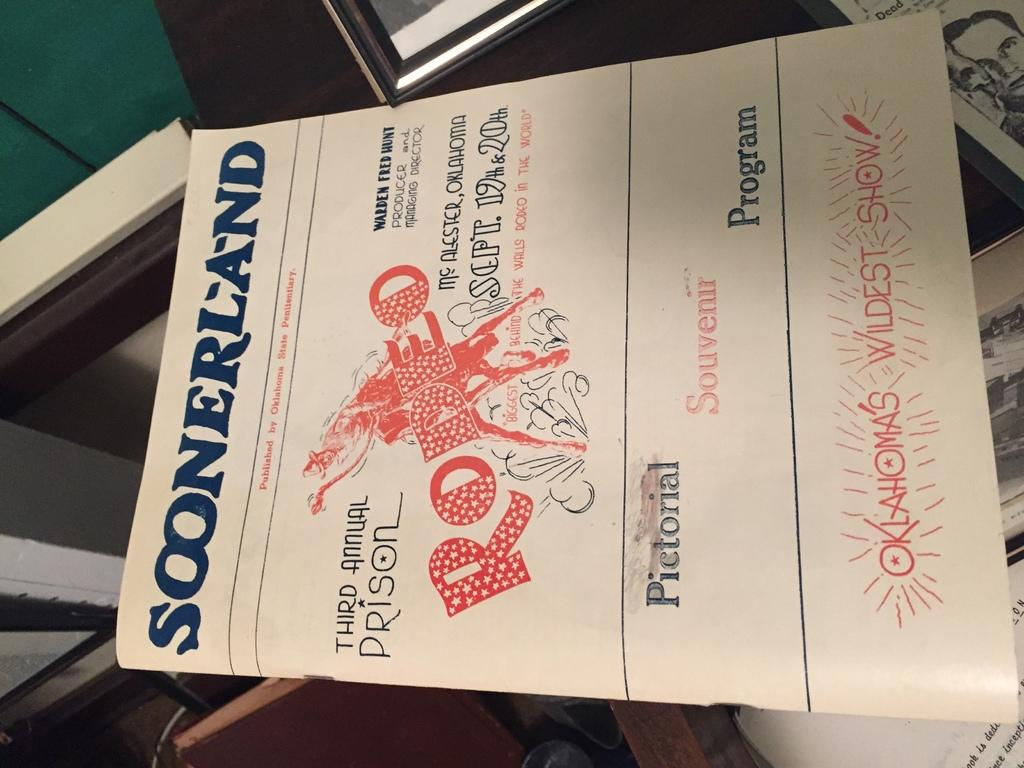<image>
Describe the image concisely. A ad for a an event on Sept. 19 & 20 at mcalester, oklahoma. 